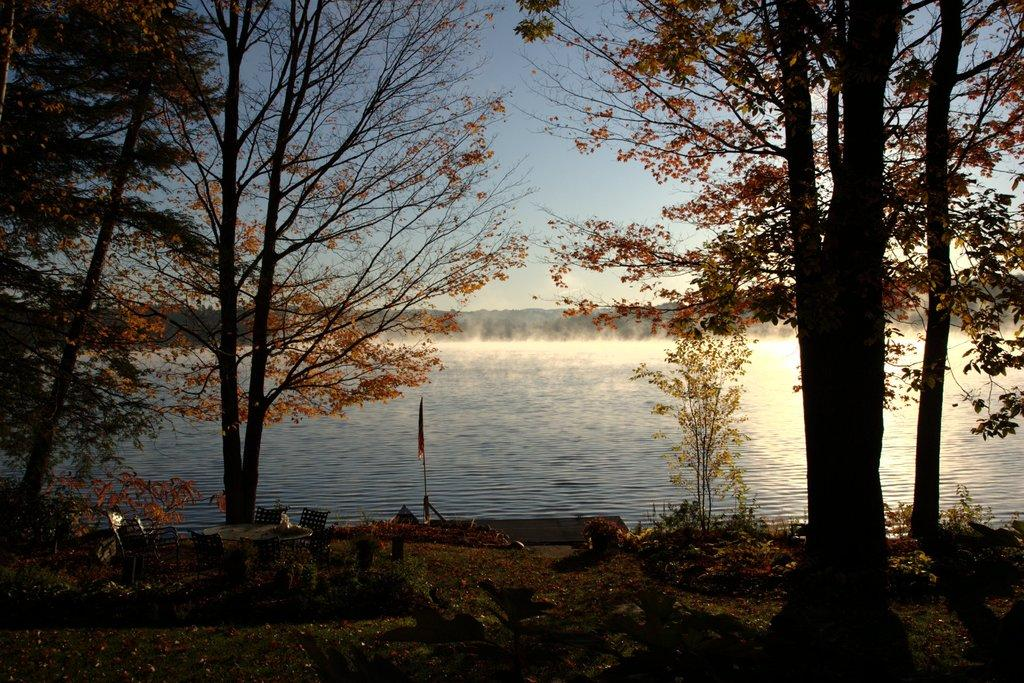What type of vegetation can be seen in the image? There is grass and plants visible in the image. What type of furniture is present in the image? There are chairs and a table in the image. What is the flag attached to in the image? The flag is attached to a pole in the image. What is the natural element visible in the image? Water is visible in the image. What type of trees are present in the image? There are trees in the image. What is visible in the background of the image? The sky is visible in the background of the image. How much money is being exchanged between the trees in the image? There is no money being exchanged in the image; it features grass, plants, chairs, a table, a flag, water, trees, and the sky. What type of nerve can be seen connecting the chairs in the image? There are no nerves present in the image, as it is a scene in nature with no biological elements. 